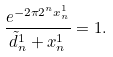Convert formula to latex. <formula><loc_0><loc_0><loc_500><loc_500>\frac { e ^ { - 2 \pi 2 ^ { n } x ^ { 1 } _ { n } } } { \tilde { d } ^ { 1 } _ { n } + x ^ { 1 } _ { n } } = 1 .</formula> 